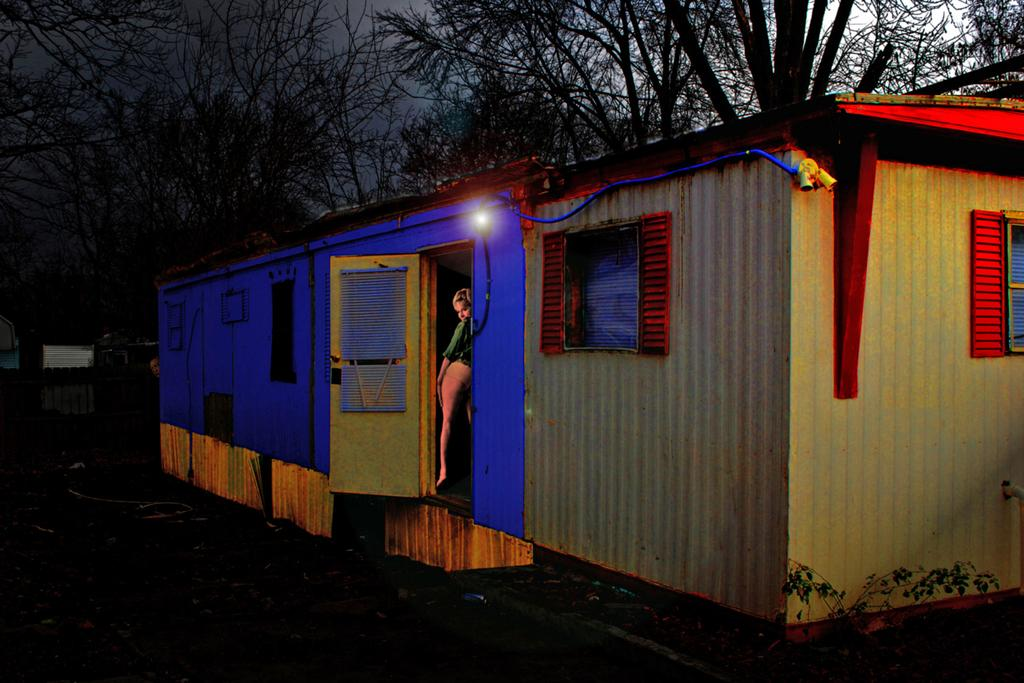What type of structure is present in the image? There is a house in the image. Who or what else can be seen in the image? There is a woman in the image. Can you describe any light source in the image? Yes, there is a light visible in the image. What can be seen in the background of the image? There are trees in the background of the image. How would you describe the overall lighting in the image? The background of the image appears dark. What type of humor does the lawyer use to stop the argument in the image? There is no lawyer or argument present in the image. 